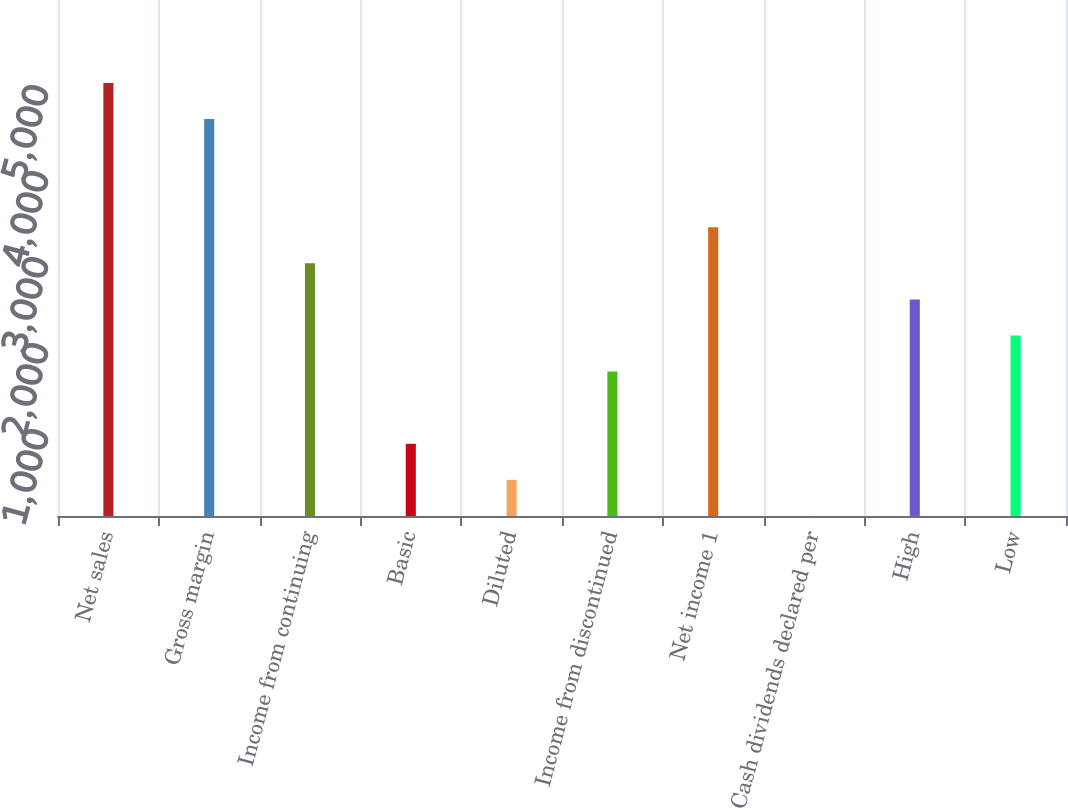Convert chart. <chart><loc_0><loc_0><loc_500><loc_500><bar_chart><fcel>Net sales<fcel>Gross margin<fcel>Income from continuing<fcel>Basic<fcel>Diluted<fcel>Income from discontinued<fcel>Net income 1<fcel>Cash dividends declared per<fcel>High<fcel>Low<nl><fcel>5036.32<fcel>4616.67<fcel>2938.07<fcel>839.82<fcel>420.17<fcel>1679.12<fcel>3357.72<fcel>0.52<fcel>2518.42<fcel>2098.77<nl></chart> 